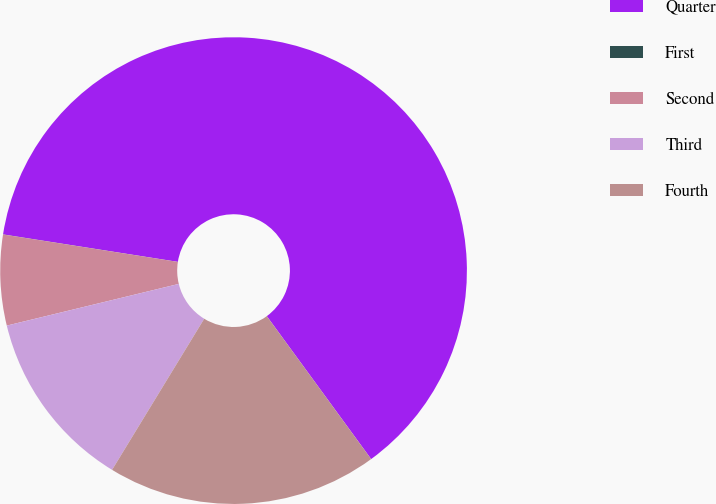Convert chart to OTSL. <chart><loc_0><loc_0><loc_500><loc_500><pie_chart><fcel>Quarter<fcel>First<fcel>Second<fcel>Third<fcel>Fourth<nl><fcel>62.48%<fcel>0.01%<fcel>6.26%<fcel>12.5%<fcel>18.75%<nl></chart> 